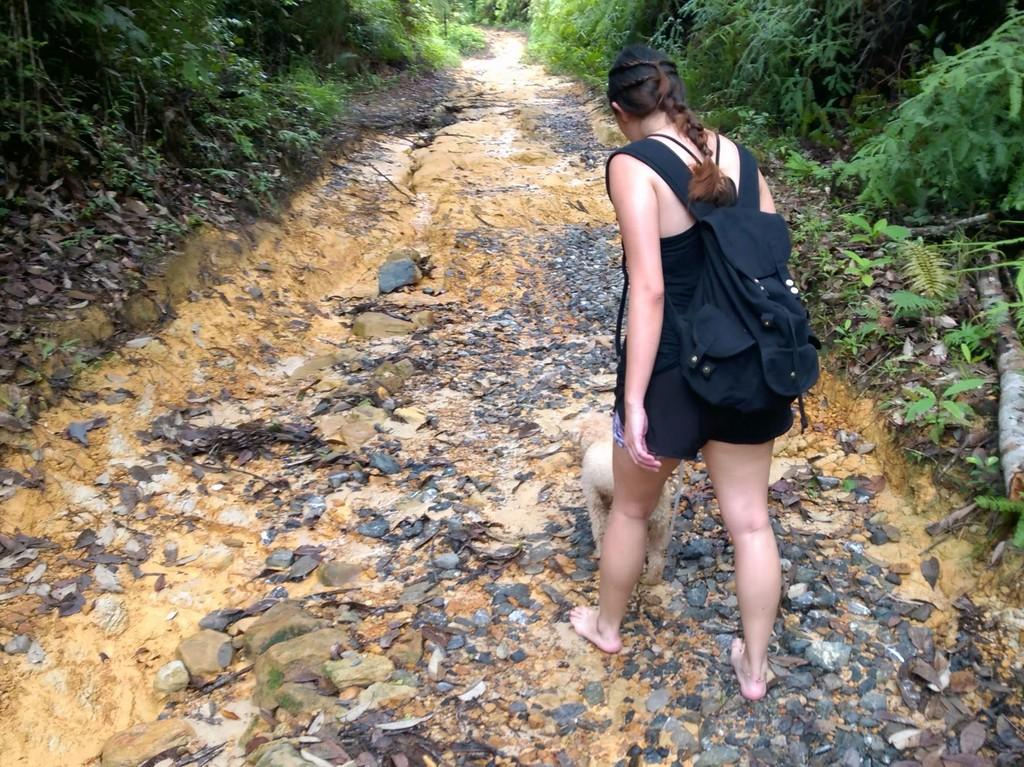Who is present in the image? There is a woman in the image. What is the woman doing in the image? The woman is standing. What is the woman wearing in the image? The woman is wearing a black dress. What is the woman carrying in the image? The woman is carrying a bag. What can be seen in the background of the image? There are trees visible in the image. What type of stove can be seen in the image? There is no stove present in the image. How does the woman stretch in the image? The woman is not stretching in the image; she is standing. 